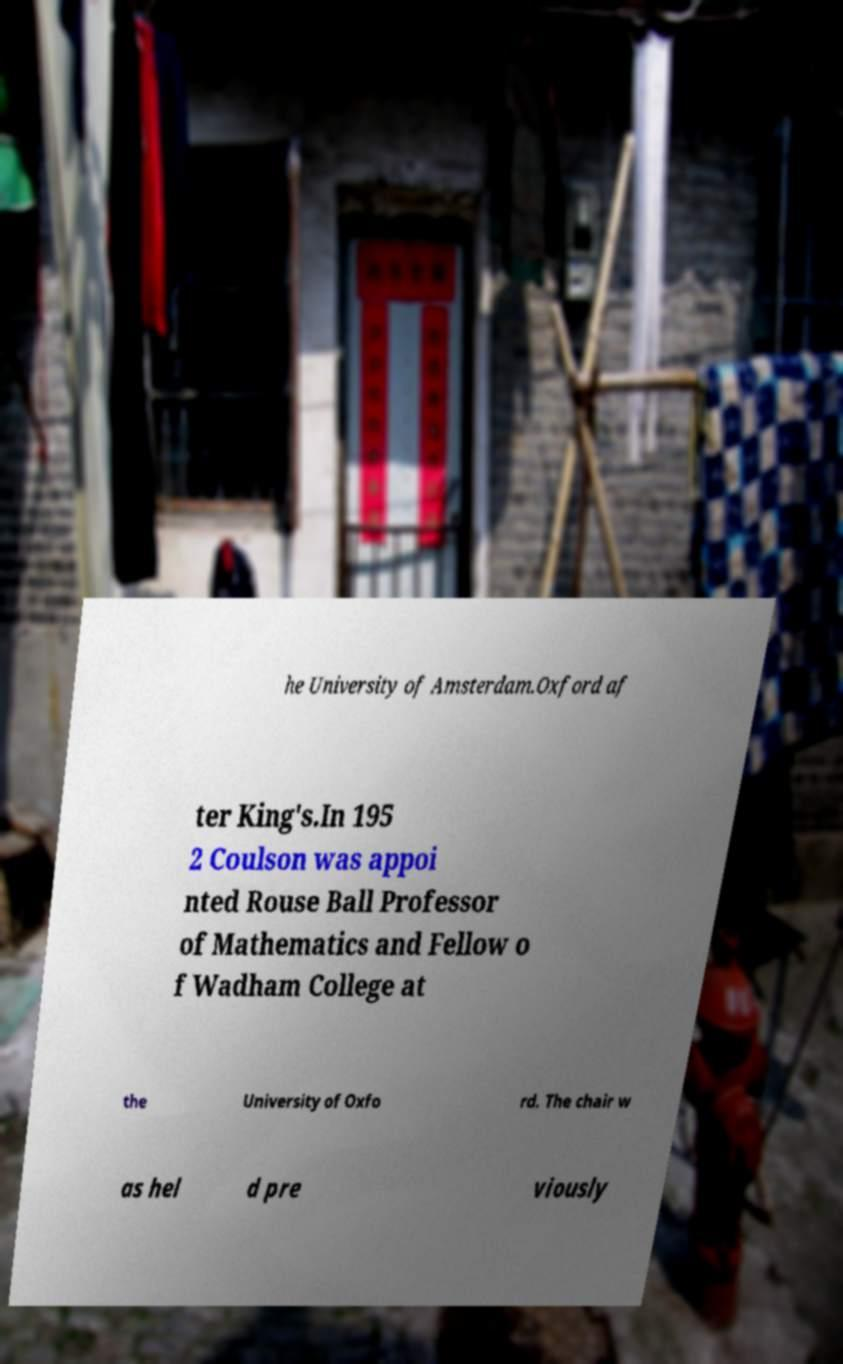Please read and relay the text visible in this image. What does it say? he University of Amsterdam.Oxford af ter King's.In 195 2 Coulson was appoi nted Rouse Ball Professor of Mathematics and Fellow o f Wadham College at the University of Oxfo rd. The chair w as hel d pre viously 